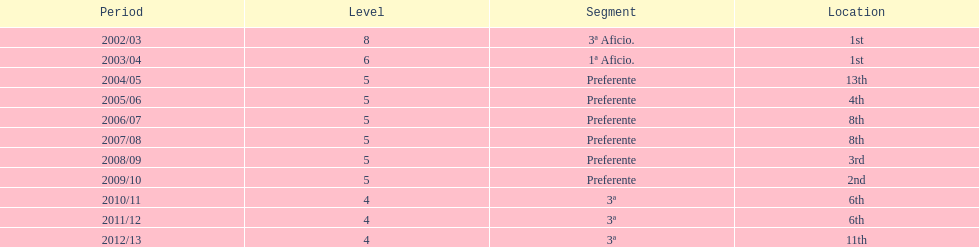For what duration was the team in the top position? 2 years. 